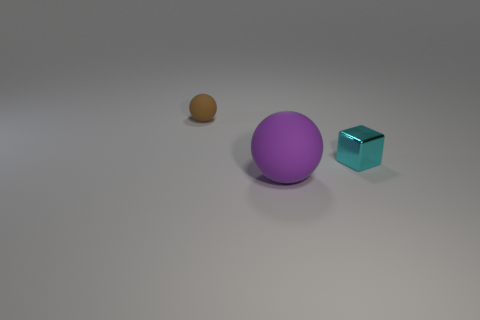Add 3 brown balls. How many objects exist? 6 Subtract all spheres. How many objects are left? 1 Add 1 large rubber things. How many large rubber things are left? 2 Add 2 tiny gray spheres. How many tiny gray spheres exist? 2 Subtract 0 yellow cylinders. How many objects are left? 3 Subtract all matte balls. Subtract all yellow things. How many objects are left? 1 